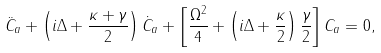Convert formula to latex. <formula><loc_0><loc_0><loc_500><loc_500>\ddot { C } _ { a } + \left ( i \Delta + \frac { \kappa + \gamma } { 2 } \right ) \dot { C } _ { a } + \left [ \frac { \Omega ^ { 2 } } { 4 } + \left ( i \Delta + \frac { \kappa } { 2 } \right ) \frac { \gamma } { 2 } \right ] C _ { a } = 0 ,</formula> 